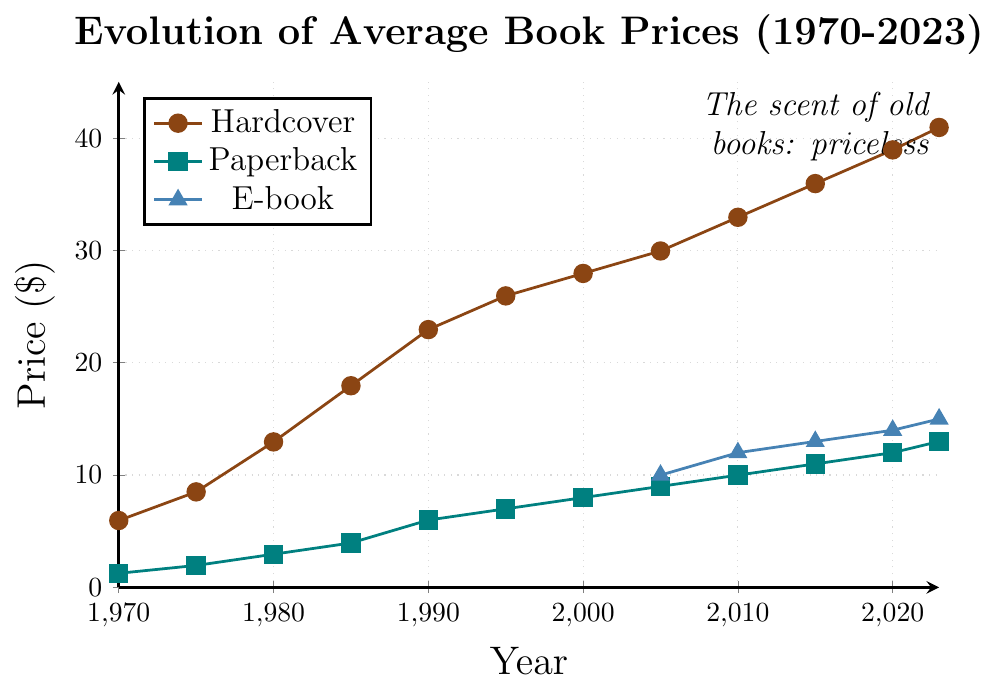What is the average price of hardcover books in the year 2000 and 2010? Take the prices of hardcover books in 2000 ($27.95) and 2010 ($32.95). Calculate the average: (27.95 + 32.95) / 2 = 30.45
Answer: 30.45 Which book format had the highest price in 2023? Compare the prices of hardcover ($40.95), paperback ($12.99), and e-book ($14.99) in 2023. The highest price is $40.95 for hardcover.
Answer: Hardcover What is the price difference between paperback and e-book in 2015? The price of paperback in 2015 is $10.99 and the price of e-book is $12.99. Calculate the difference: 12.99 - 10.99 = 2.00
Answer: 2.00 How much more expensive is the hardcover book in 2023 compared to 1970? The price of hardcover in 2023 is $40.95, and in 1970 it is $5.95. Calculate the difference: 40.95 - 5.95 = 35.00
Answer: 35.00 Which year shows the biggest increase in paperback prices? Compare the price increases from each year. The biggest increase is between 1985 ($3.95) and 1990 ($5.99), where the increase is 5.99 - 3.95 = 2.04
Answer: 1990 What is the combined price of all book formats in 2020? Combine the prices of hardcover ($38.95), paperback ($11.99), and e-book ($13.99) in 2020: 38.95 + 11.99 + 13.99 = 64.93
Answer: 64.93 How does the price trend for e-books compare to paperbacks from 2005 to 2023? E-book prices start at $9.99 in 2005 and rise to $14.99 in 2023, while paperback prices increase from $8.99 in 2005 to $12.99 in 2023. Both trends are upward, but e-books have smaller incremental increases.
Answer: Upward, smaller increments for e-books What is the increase in price for hardcover books from 1970 to 1980? The price of hardcover books in 1970 is $5.95 and in 1980 is $12.95. Calculate the difference: 12.95 - 5.95 = 7.00
Answer: 7.00 If you average the prices of paperback books for the first three data points, what is the result? Take the prices of paperback books in 1970 ($1.25), 1975 ($1.95), and 1980 ($2.95). Calculate the average: (1.25 + 1.95 + 2.95) / 3 = 2.05
Answer: 2.05 